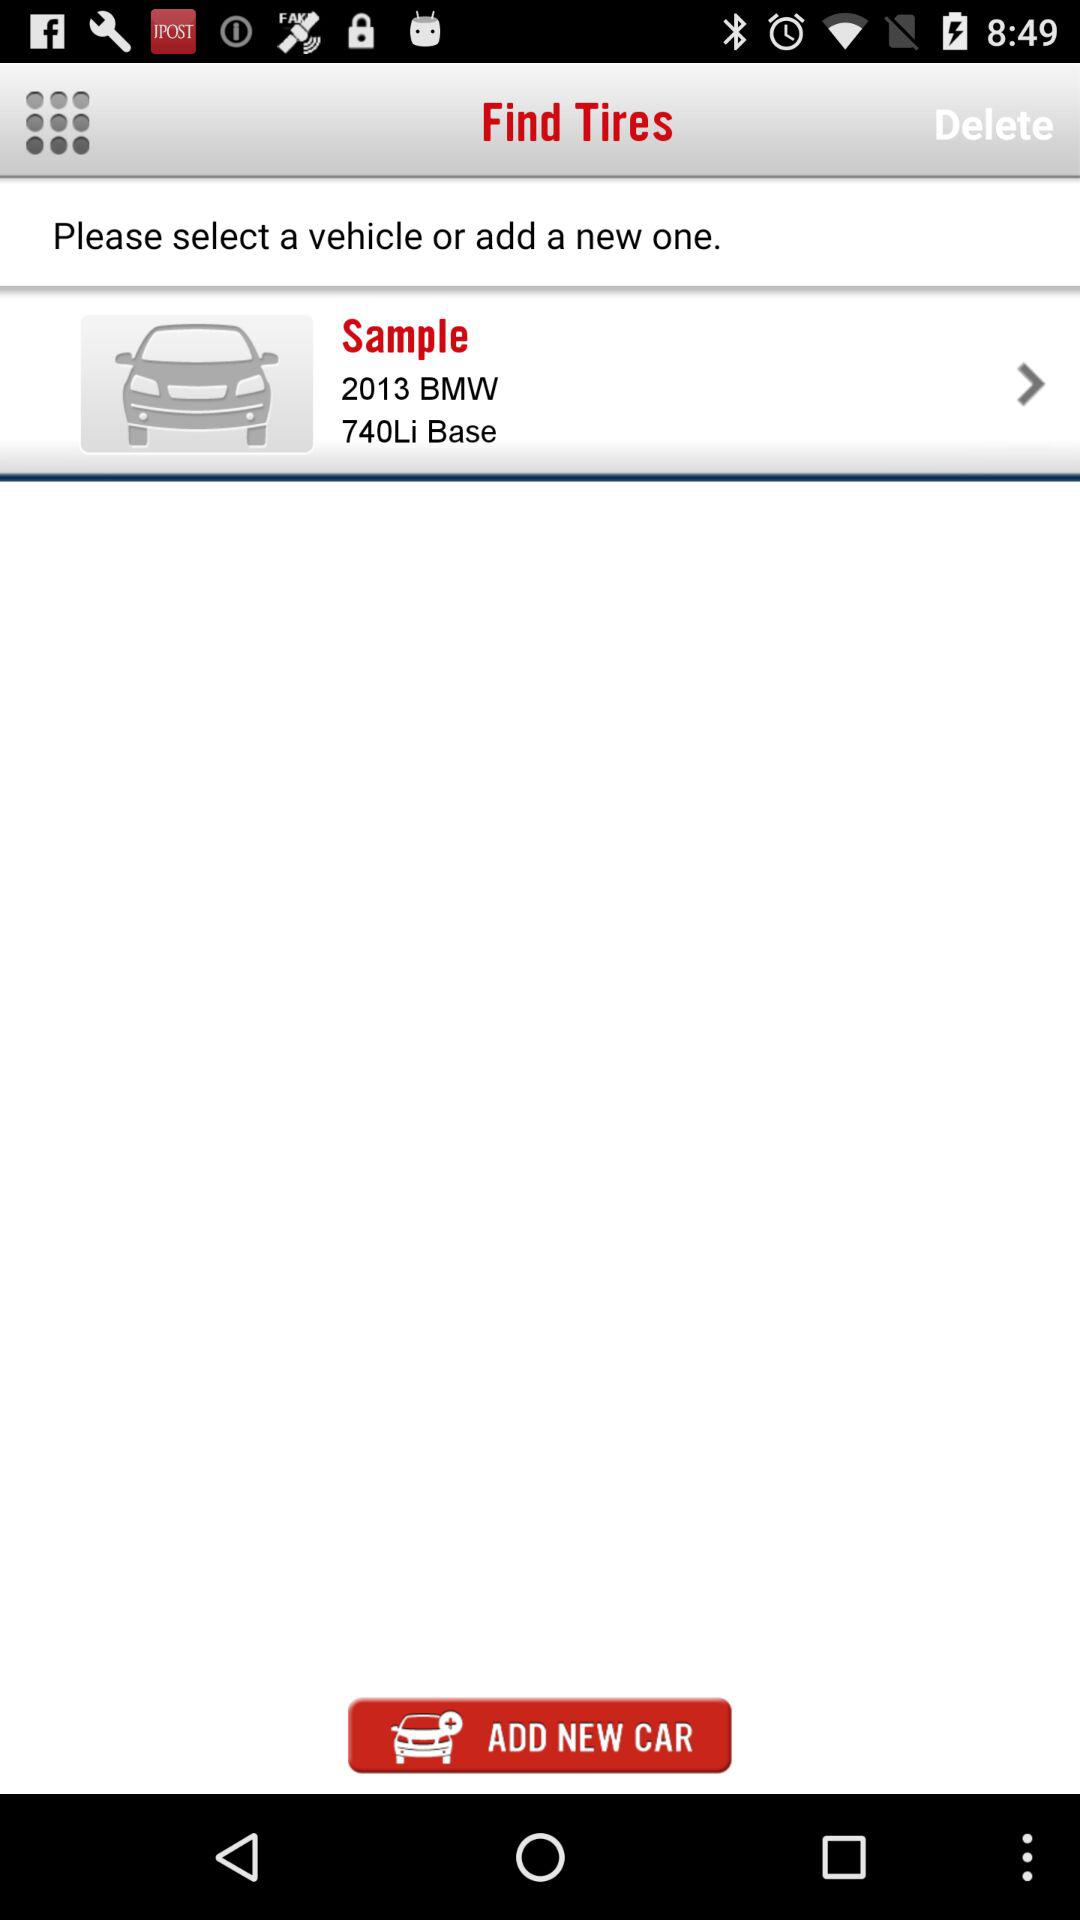What is the battery capacity?
When the provided information is insufficient, respond with <no answer>. <no answer> 